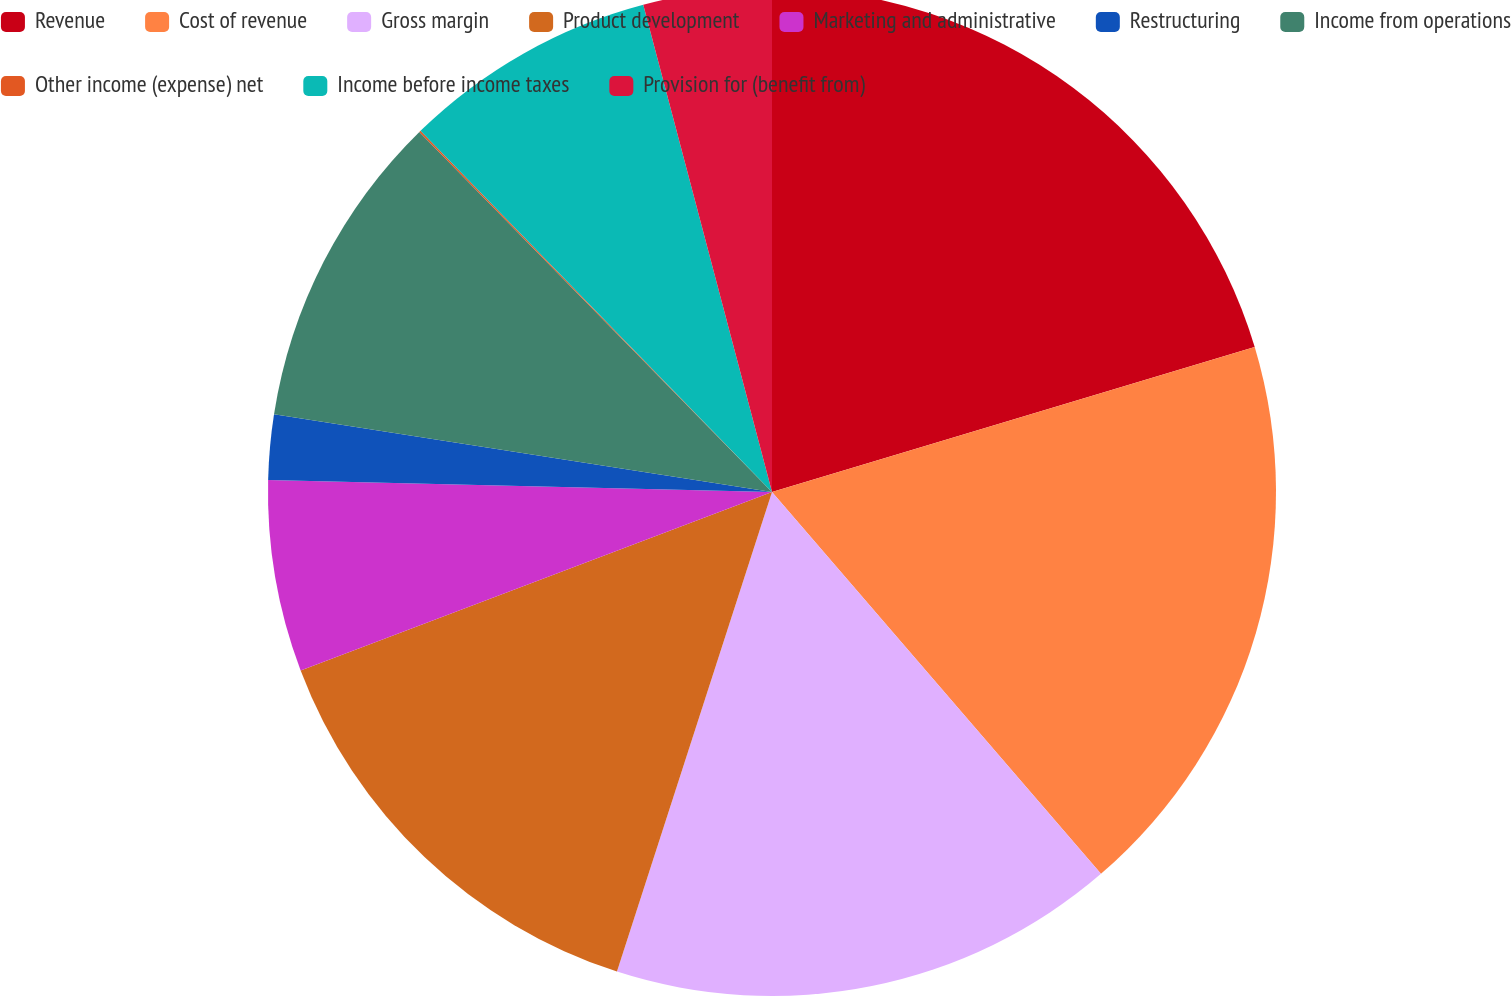Convert chart to OTSL. <chart><loc_0><loc_0><loc_500><loc_500><pie_chart><fcel>Revenue<fcel>Cost of revenue<fcel>Gross margin<fcel>Product development<fcel>Marketing and administrative<fcel>Restructuring<fcel>Income from operations<fcel>Other income (expense) net<fcel>Income before income taxes<fcel>Provision for (benefit from)<nl><fcel>20.35%<fcel>18.32%<fcel>16.29%<fcel>14.26%<fcel>6.14%<fcel>2.08%<fcel>10.2%<fcel>0.05%<fcel>8.17%<fcel>4.11%<nl></chart> 